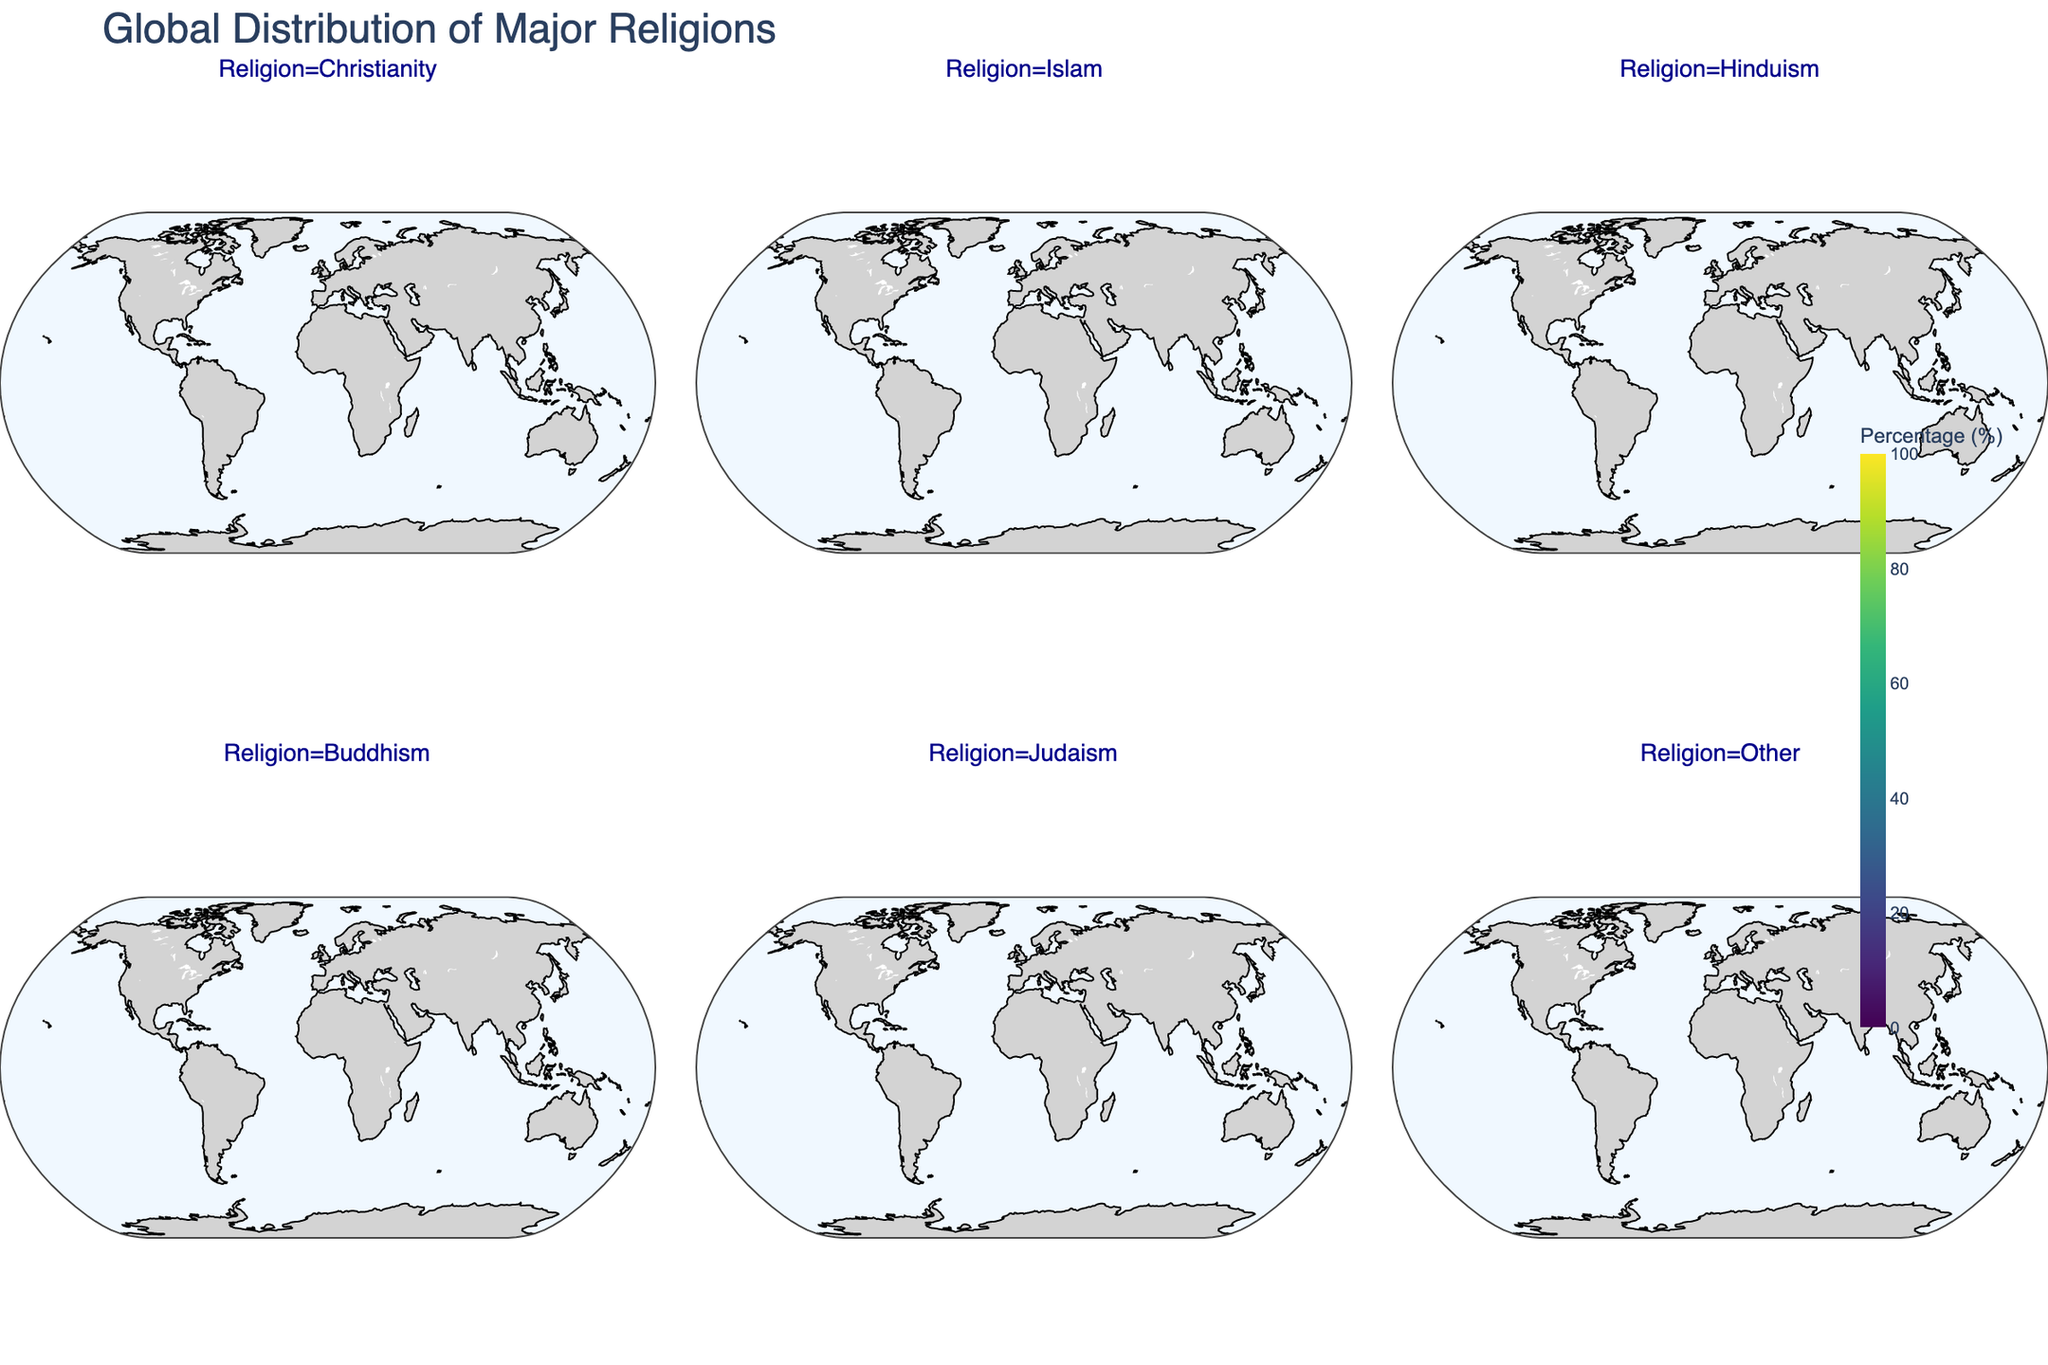What is the title of the figure? The title is displayed at the top center of the figure.
Answer: Global Distribution of Major Religions Which religion shows the highest percentage in South America? The plot for South America in the Christianity facet shows the highest percentage value compared to other religions.
Answer: Christianity How does the percentage of Islam in North Africa compare to its percentage in Sub-Saharan Africa? In the plot, North Africa's percentage for Islam is significantly higher at 90%, while Sub-Saharan Africa is shown to have 30%.
Answer: North Africa has a higher percentage Which region has the highest percentage of Buddhism? By examining all the plots, the Southeast Asia facet displays the highest percentage for Buddhism at 40%.
Answer: Southeast Asia What is the combined percentage of Christianity and Islam in Western Europe? Christianity in Western Europe shows 70%, and Islam shows 5%. Adding these percentages gives 70 + 5 = 75%.
Answer: 75% Which regions have a percentage of Hinduism of 5% or more? By reviewing all facets, the regions with Hinduism at 5% or more are South Asia (60%), Southeast Asia (5%), and Oceania (2%).
Answer: South Asia, Southeast Asia, Oceania How does the percentage of Judaism in North America compare to that in Eastern Europe? From the regional plots, Judaism in North America shows 2%, whereas Eastern Europe shows 0.5%.
Answer: North America has a higher percentage In which region is the percentage of other religions highest? The facet for Other religions indicates East Asia has the highest percentage at 72.4%.
Answer: East Asia What is the average percentage of Islam in the Middle East and Central Asia? Islam in the Middle East is 90%, and in Central Asia, it is 70%. The average is calculated as (90 + 70) / 2 = 80%.
Answer: 80% Which region has the lowest percentage of Christianity? By looking at all the regional plots for Christianity, the Middle East and North Africa both show the lowest percentage at 5%.
Answer: Middle East and North Africa 